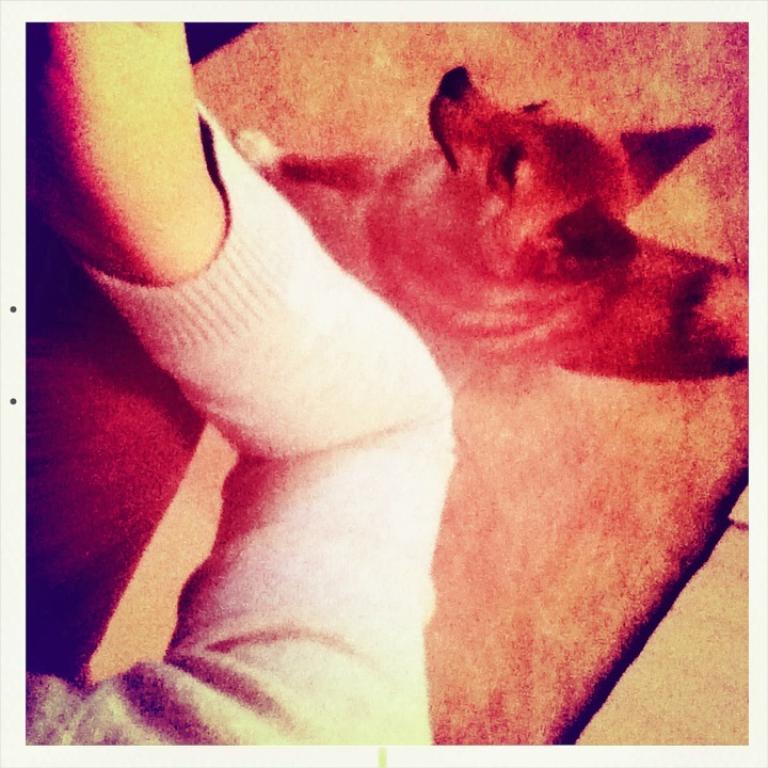Can you describe this image briefly? In this image I can see a dog. In the left side I can see a hand with white cloth. 